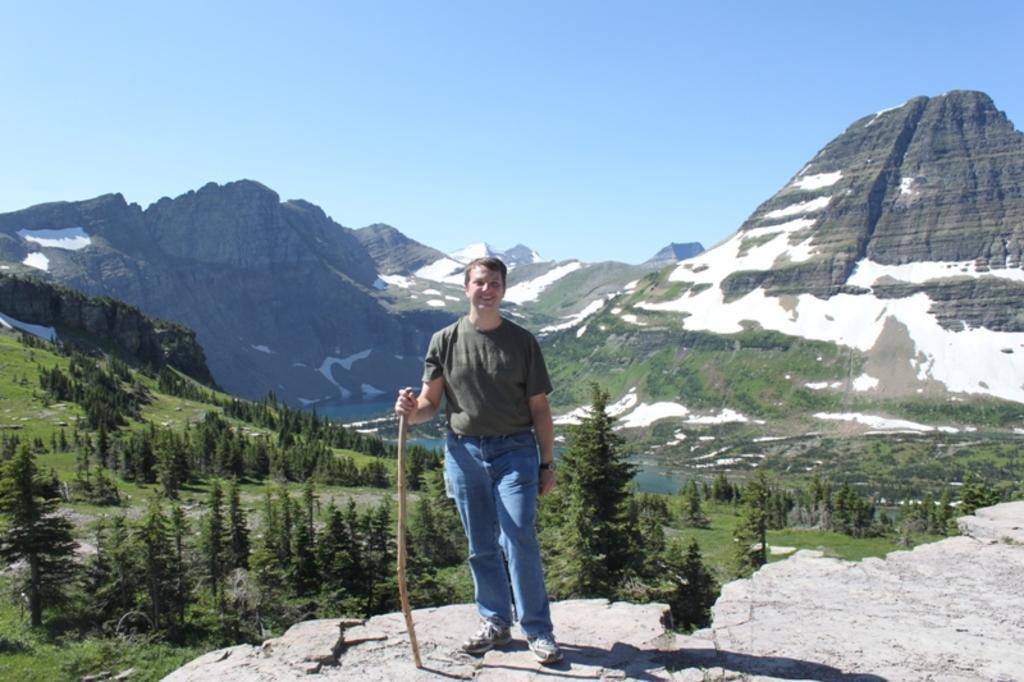Describe this image in one or two sentences. In this picture we can see a person holding a stick and smiling. There are a few planets visible from left to right. We can see some mountains covered with a snow in the background. Sky is blue in color. 